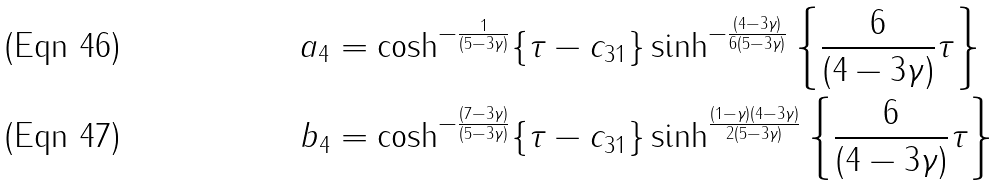<formula> <loc_0><loc_0><loc_500><loc_500>a _ { 4 } & = \cosh ^ { - \frac { 1 } { ( 5 - 3 \gamma ) } } \{ \tau - c _ { 3 1 } \} \sinh ^ { - \frac { ( 4 - 3 \gamma ) } { 6 ( 5 - 3 \gamma ) } } \left \{ \frac { 6 } { ( 4 - 3 \gamma ) } \tau \right \} \\ b _ { 4 } & = \cosh ^ { - \frac { ( 7 - 3 \gamma ) } { ( 5 - 3 \gamma ) } } \{ \tau - c _ { 3 1 } \} \sinh ^ { \frac { ( 1 - \gamma ) ( 4 - 3 \gamma ) } { 2 ( 5 - 3 \gamma ) } } \left \{ \frac { 6 } { ( 4 - 3 \gamma ) } \tau \right \}</formula> 